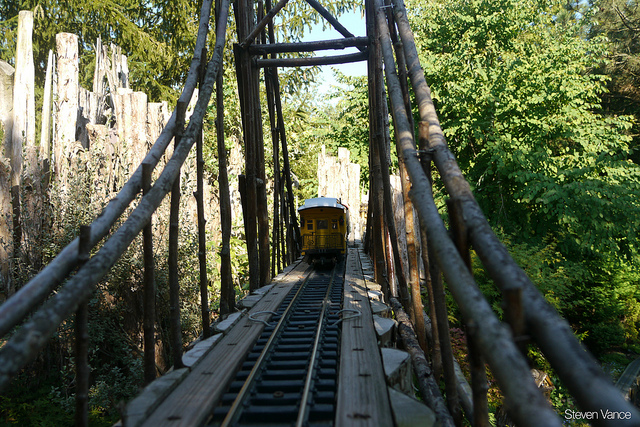Identify and read out the text in this image. Steven Vance 